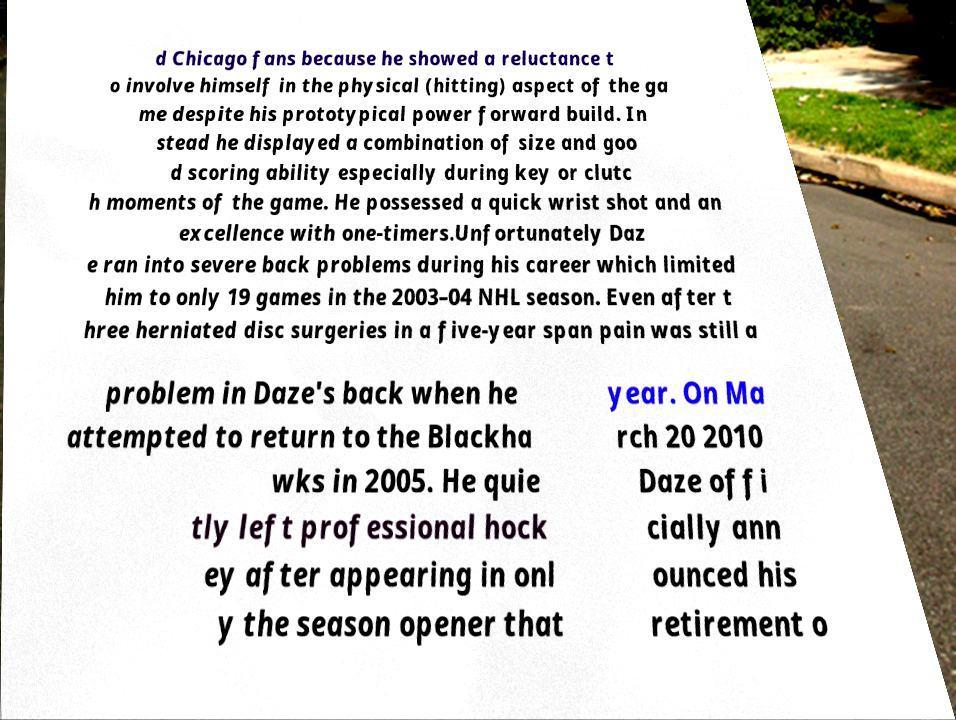Could you assist in decoding the text presented in this image and type it out clearly? d Chicago fans because he showed a reluctance t o involve himself in the physical (hitting) aspect of the ga me despite his prototypical power forward build. In stead he displayed a combination of size and goo d scoring ability especially during key or clutc h moments of the game. He possessed a quick wrist shot and an excellence with one-timers.Unfortunately Daz e ran into severe back problems during his career which limited him to only 19 games in the 2003–04 NHL season. Even after t hree herniated disc surgeries in a five-year span pain was still a problem in Daze's back when he attempted to return to the Blackha wks in 2005. He quie tly left professional hock ey after appearing in onl y the season opener that year. On Ma rch 20 2010 Daze offi cially ann ounced his retirement o 